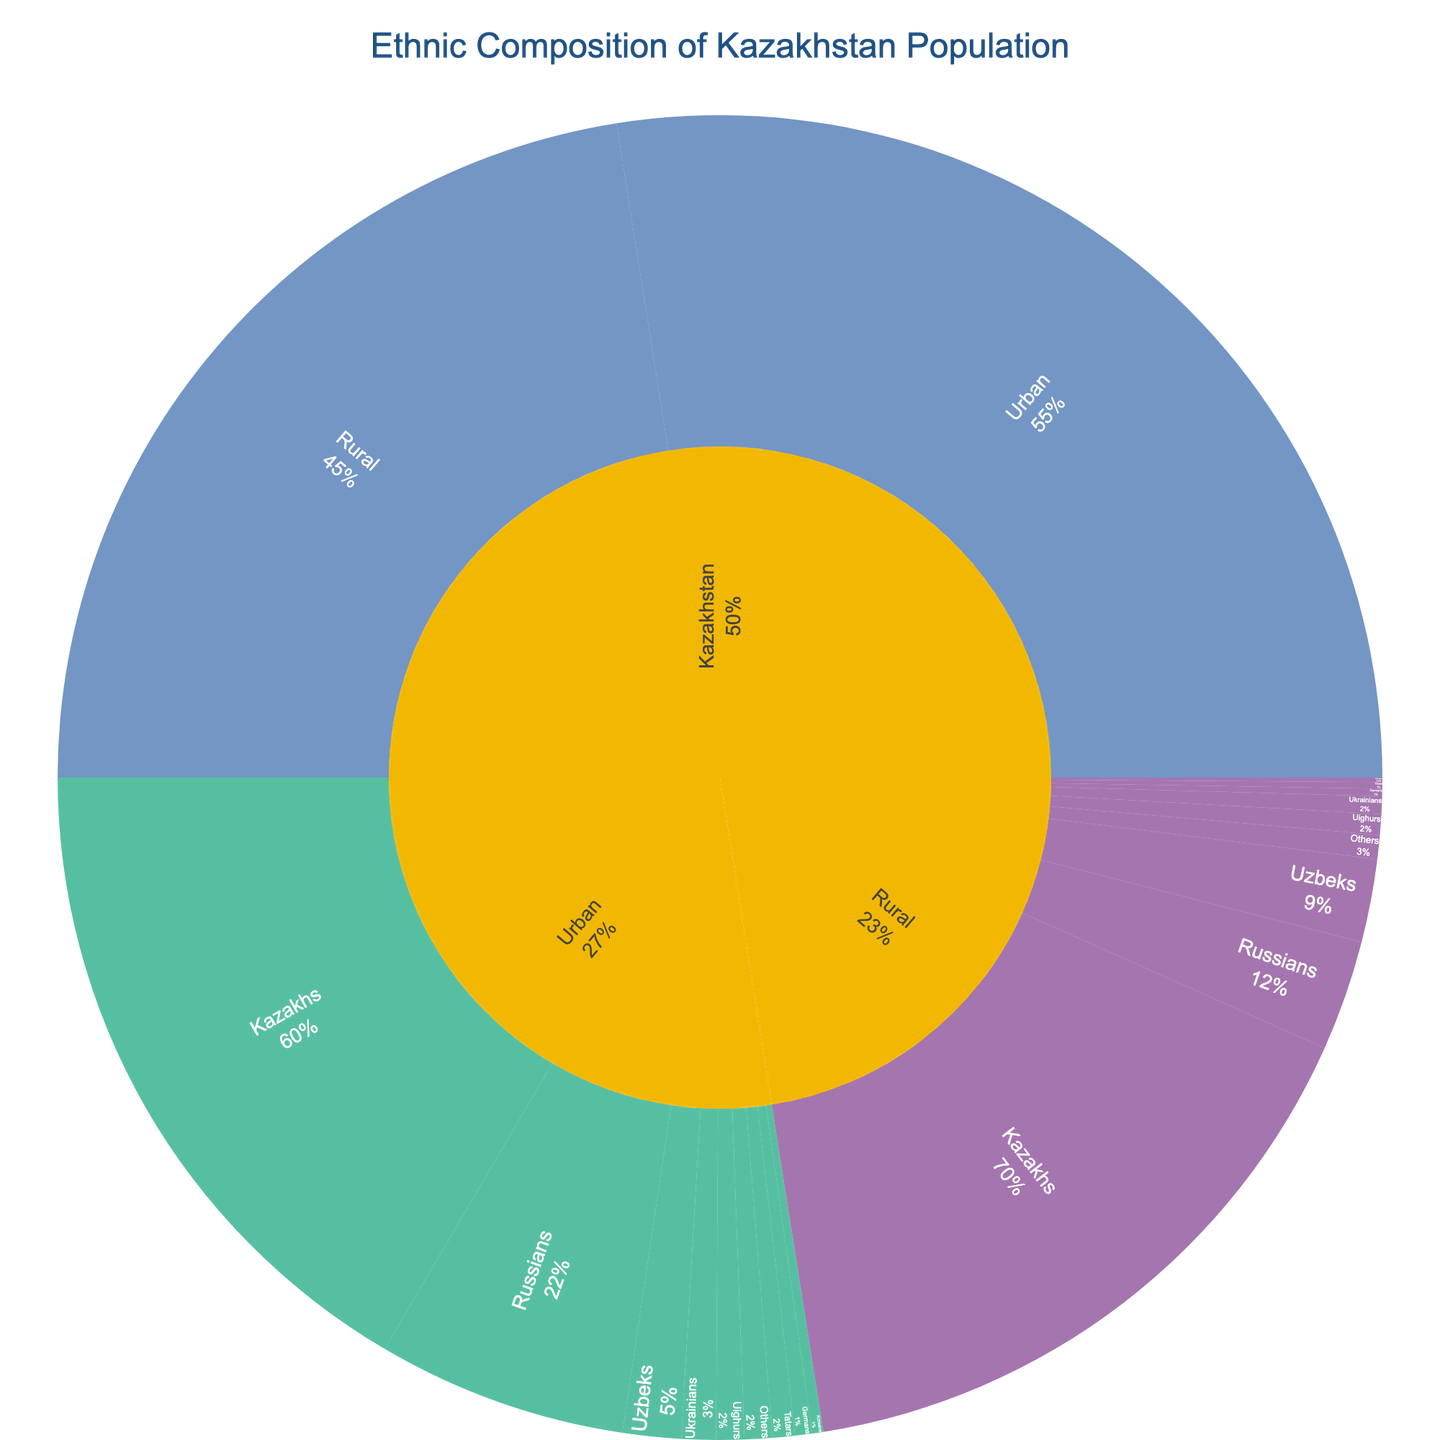What is the title of the sunburst plot? The title of the plot is displayed at the top and is clearly centered in larger, bold font. The title summarizes the content of the plot.
Answer: Ethnic Composition of Kazakhstan Population What is the population of urban Kazakhs? To find this, you need to look at the section of the sunburst plot labeled "Urban," then find the sub-section labeled "Kazakhs." The value associated with this section provides the population.
Answer: 6,391,316 Which ethnic group has the smallest population in rural areas? Focus on the sections under "Rural" in the sunburst plot. Compare the values for all ethnic groups to identify the smallest one.
Answer: Koreans How much larger is the urban population compared to the rural population? Find the values for "Urban" and "Rural" populations in the main sections of the sunburst plot, then subtract the rural population from the urban population.
Answer: 1,926,768 What percentage of the urban population are Russians? To calculate this, find the urban population of Russians and divide it by the total urban population, then multiply by 100 to get the percentage.
Answer: 22.1% Which ethnic group has the larger difference in population between urban and rural areas, Kazakhs or Russians? Calculate the difference in population for both Kazakhs and Russians between urban and rural areas. For Kazakhs: Urban 6,391,316 - Rural 6,103,220 = 288,096. For Russians: Urban 2,352,015 - Rural 1,042,637 = 1,309,378. Russians have the larger difference.
Answer: Russians How does the population of Koreans in rural areas compare to that in urban areas? Find the population values for Koreans under "Urban" and "Rural" sections. Compare the two values to see which one is higher or if they are equal.
Answer: Urban Koreans is more What is the total population of Uzbeks in Kazakhstan? Add the population of Uzbeks in both urban and rural sections. Urban Uzbeks: 548,892. Rural Uzbeks: 782,178. Total: 548,892 + 782,178 = 1,331,070.
Answer: 1,331,070 Which ethnic group names are represented both in urban and rural populations? Look at the ethnic groups listed in both the "Urban" and "Rural" sections of the sunburst plot. The groups present in both sections are the ones represented in both populations.
Answer: Kazakhs, Russians, Uzbeks, Ukrainians, Uighurs, Tatars, Germans, Koreans, Others 